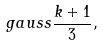Convert formula to latex. <formula><loc_0><loc_0><loc_500><loc_500>\ g a u s s { \frac { k + 1 } { 3 } } ,</formula> 